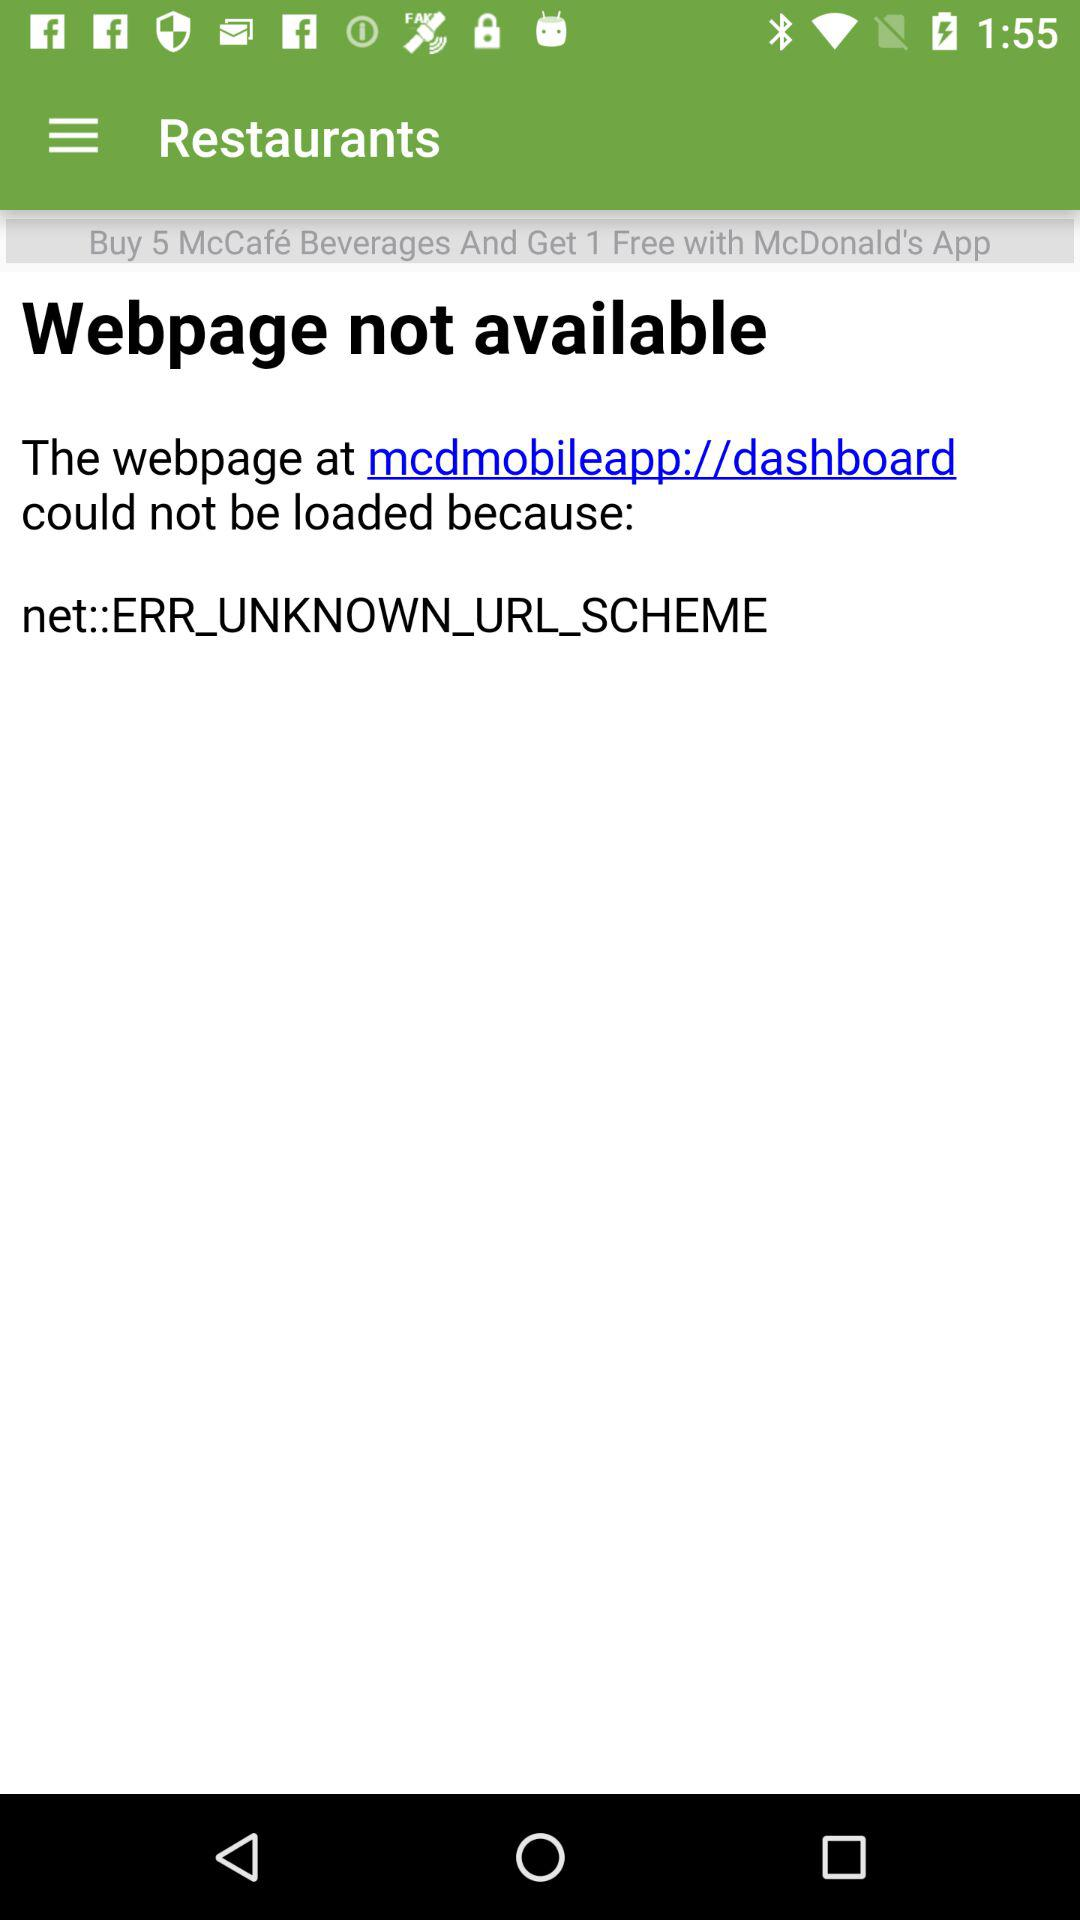On buying how many McCafe beverages will I get one free? On buying 5 McCafe beverages, you will get one free. 